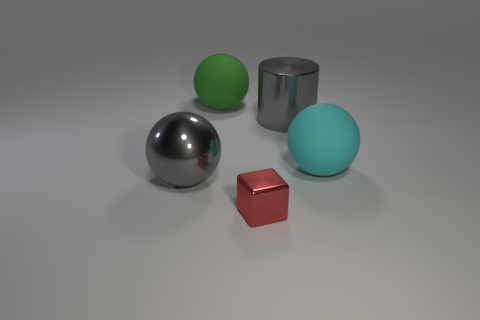Subtract all large gray spheres. How many spheres are left? 2 Subtract 1 cubes. How many cubes are left? 0 Add 4 tiny metal blocks. How many objects exist? 9 Subtract all spheres. How many objects are left? 2 Add 2 blue matte spheres. How many blue matte spheres exist? 2 Subtract 0 purple cylinders. How many objects are left? 5 Subtract all brown cylinders. Subtract all yellow spheres. How many cylinders are left? 1 Subtract all big cylinders. Subtract all green balls. How many objects are left? 3 Add 4 tiny red blocks. How many tiny red blocks are left? 5 